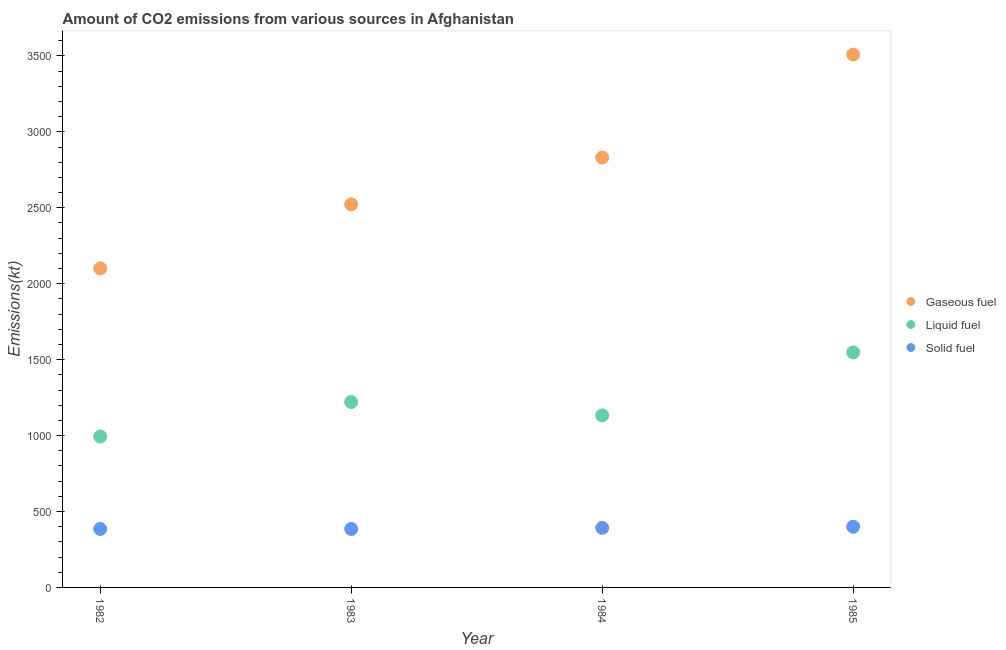What is the amount of co2 emissions from liquid fuel in 1984?
Offer a terse response. 1133.1. Across all years, what is the maximum amount of co2 emissions from solid fuel?
Offer a very short reply. 399.7. Across all years, what is the minimum amount of co2 emissions from solid fuel?
Offer a very short reply. 385.04. In which year was the amount of co2 emissions from gaseous fuel maximum?
Provide a short and direct response. 1985. What is the total amount of co2 emissions from solid fuel in the graph?
Give a very brief answer. 1562.14. What is the difference between the amount of co2 emissions from gaseous fuel in 1984 and that in 1985?
Give a very brief answer. -678.39. What is the difference between the amount of co2 emissions from gaseous fuel in 1983 and the amount of co2 emissions from liquid fuel in 1984?
Offer a very short reply. 1389.79. What is the average amount of co2 emissions from liquid fuel per year?
Keep it short and to the point. 1223.86. In the year 1983, what is the difference between the amount of co2 emissions from gaseous fuel and amount of co2 emissions from liquid fuel?
Provide a short and direct response. 1301.79. What is the ratio of the amount of co2 emissions from gaseous fuel in 1982 to that in 1983?
Provide a succinct answer. 0.83. Is the amount of co2 emissions from liquid fuel in 1983 less than that in 1985?
Make the answer very short. Yes. What is the difference between the highest and the second highest amount of co2 emissions from gaseous fuel?
Keep it short and to the point. 678.39. What is the difference between the highest and the lowest amount of co2 emissions from solid fuel?
Make the answer very short. 14.67. In how many years, is the amount of co2 emissions from liquid fuel greater than the average amount of co2 emissions from liquid fuel taken over all years?
Make the answer very short. 1. Is the sum of the amount of co2 emissions from liquid fuel in 1982 and 1985 greater than the maximum amount of co2 emissions from solid fuel across all years?
Provide a succinct answer. Yes. Does the amount of co2 emissions from gaseous fuel monotonically increase over the years?
Provide a short and direct response. Yes. How many dotlines are there?
Your answer should be compact. 3. How many years are there in the graph?
Your answer should be very brief. 4. Does the graph contain any zero values?
Ensure brevity in your answer.  No. Does the graph contain grids?
Your answer should be very brief. No. Where does the legend appear in the graph?
Your answer should be compact. Center right. What is the title of the graph?
Ensure brevity in your answer.  Amount of CO2 emissions from various sources in Afghanistan. What is the label or title of the X-axis?
Offer a very short reply. Year. What is the label or title of the Y-axis?
Your answer should be compact. Emissions(kt). What is the Emissions(kt) in Gaseous fuel in 1982?
Offer a terse response. 2101.19. What is the Emissions(kt) of Liquid fuel in 1982?
Your response must be concise. 993.76. What is the Emissions(kt) in Solid fuel in 1982?
Offer a terse response. 385.04. What is the Emissions(kt) of Gaseous fuel in 1983?
Your answer should be compact. 2522.9. What is the Emissions(kt) of Liquid fuel in 1983?
Give a very brief answer. 1221.11. What is the Emissions(kt) of Solid fuel in 1983?
Your answer should be very brief. 385.04. What is the Emissions(kt) in Gaseous fuel in 1984?
Your answer should be very brief. 2830.92. What is the Emissions(kt) in Liquid fuel in 1984?
Offer a terse response. 1133.1. What is the Emissions(kt) of Solid fuel in 1984?
Keep it short and to the point. 392.37. What is the Emissions(kt) of Gaseous fuel in 1985?
Ensure brevity in your answer.  3509.32. What is the Emissions(kt) in Liquid fuel in 1985?
Provide a succinct answer. 1547.47. What is the Emissions(kt) in Solid fuel in 1985?
Give a very brief answer. 399.7. Across all years, what is the maximum Emissions(kt) of Gaseous fuel?
Keep it short and to the point. 3509.32. Across all years, what is the maximum Emissions(kt) in Liquid fuel?
Ensure brevity in your answer.  1547.47. Across all years, what is the maximum Emissions(kt) of Solid fuel?
Your response must be concise. 399.7. Across all years, what is the minimum Emissions(kt) in Gaseous fuel?
Make the answer very short. 2101.19. Across all years, what is the minimum Emissions(kt) of Liquid fuel?
Make the answer very short. 993.76. Across all years, what is the minimum Emissions(kt) of Solid fuel?
Provide a succinct answer. 385.04. What is the total Emissions(kt) of Gaseous fuel in the graph?
Make the answer very short. 1.10e+04. What is the total Emissions(kt) of Liquid fuel in the graph?
Your answer should be very brief. 4895.44. What is the total Emissions(kt) of Solid fuel in the graph?
Your answer should be very brief. 1562.14. What is the difference between the Emissions(kt) of Gaseous fuel in 1982 and that in 1983?
Give a very brief answer. -421.7. What is the difference between the Emissions(kt) in Liquid fuel in 1982 and that in 1983?
Keep it short and to the point. -227.35. What is the difference between the Emissions(kt) of Solid fuel in 1982 and that in 1983?
Ensure brevity in your answer.  0. What is the difference between the Emissions(kt) in Gaseous fuel in 1982 and that in 1984?
Your response must be concise. -729.73. What is the difference between the Emissions(kt) of Liquid fuel in 1982 and that in 1984?
Ensure brevity in your answer.  -139.35. What is the difference between the Emissions(kt) of Solid fuel in 1982 and that in 1984?
Offer a very short reply. -7.33. What is the difference between the Emissions(kt) in Gaseous fuel in 1982 and that in 1985?
Your response must be concise. -1408.13. What is the difference between the Emissions(kt) of Liquid fuel in 1982 and that in 1985?
Your answer should be compact. -553.72. What is the difference between the Emissions(kt) of Solid fuel in 1982 and that in 1985?
Make the answer very short. -14.67. What is the difference between the Emissions(kt) in Gaseous fuel in 1983 and that in 1984?
Give a very brief answer. -308.03. What is the difference between the Emissions(kt) of Liquid fuel in 1983 and that in 1984?
Ensure brevity in your answer.  88.01. What is the difference between the Emissions(kt) in Solid fuel in 1983 and that in 1984?
Ensure brevity in your answer.  -7.33. What is the difference between the Emissions(kt) in Gaseous fuel in 1983 and that in 1985?
Make the answer very short. -986.42. What is the difference between the Emissions(kt) of Liquid fuel in 1983 and that in 1985?
Provide a short and direct response. -326.36. What is the difference between the Emissions(kt) of Solid fuel in 1983 and that in 1985?
Your answer should be very brief. -14.67. What is the difference between the Emissions(kt) in Gaseous fuel in 1984 and that in 1985?
Provide a short and direct response. -678.39. What is the difference between the Emissions(kt) of Liquid fuel in 1984 and that in 1985?
Offer a very short reply. -414.37. What is the difference between the Emissions(kt) in Solid fuel in 1984 and that in 1985?
Provide a succinct answer. -7.33. What is the difference between the Emissions(kt) of Gaseous fuel in 1982 and the Emissions(kt) of Liquid fuel in 1983?
Keep it short and to the point. 880.08. What is the difference between the Emissions(kt) of Gaseous fuel in 1982 and the Emissions(kt) of Solid fuel in 1983?
Keep it short and to the point. 1716.16. What is the difference between the Emissions(kt) of Liquid fuel in 1982 and the Emissions(kt) of Solid fuel in 1983?
Your response must be concise. 608.72. What is the difference between the Emissions(kt) in Gaseous fuel in 1982 and the Emissions(kt) in Liquid fuel in 1984?
Your answer should be compact. 968.09. What is the difference between the Emissions(kt) of Gaseous fuel in 1982 and the Emissions(kt) of Solid fuel in 1984?
Your answer should be very brief. 1708.82. What is the difference between the Emissions(kt) in Liquid fuel in 1982 and the Emissions(kt) in Solid fuel in 1984?
Your response must be concise. 601.39. What is the difference between the Emissions(kt) of Gaseous fuel in 1982 and the Emissions(kt) of Liquid fuel in 1985?
Keep it short and to the point. 553.72. What is the difference between the Emissions(kt) of Gaseous fuel in 1982 and the Emissions(kt) of Solid fuel in 1985?
Provide a succinct answer. 1701.49. What is the difference between the Emissions(kt) in Liquid fuel in 1982 and the Emissions(kt) in Solid fuel in 1985?
Your answer should be compact. 594.05. What is the difference between the Emissions(kt) in Gaseous fuel in 1983 and the Emissions(kt) in Liquid fuel in 1984?
Keep it short and to the point. 1389.79. What is the difference between the Emissions(kt) in Gaseous fuel in 1983 and the Emissions(kt) in Solid fuel in 1984?
Offer a terse response. 2130.53. What is the difference between the Emissions(kt) in Liquid fuel in 1983 and the Emissions(kt) in Solid fuel in 1984?
Your answer should be compact. 828.74. What is the difference between the Emissions(kt) in Gaseous fuel in 1983 and the Emissions(kt) in Liquid fuel in 1985?
Ensure brevity in your answer.  975.42. What is the difference between the Emissions(kt) of Gaseous fuel in 1983 and the Emissions(kt) of Solid fuel in 1985?
Make the answer very short. 2123.19. What is the difference between the Emissions(kt) of Liquid fuel in 1983 and the Emissions(kt) of Solid fuel in 1985?
Offer a terse response. 821.41. What is the difference between the Emissions(kt) of Gaseous fuel in 1984 and the Emissions(kt) of Liquid fuel in 1985?
Keep it short and to the point. 1283.45. What is the difference between the Emissions(kt) of Gaseous fuel in 1984 and the Emissions(kt) of Solid fuel in 1985?
Offer a terse response. 2431.22. What is the difference between the Emissions(kt) in Liquid fuel in 1984 and the Emissions(kt) in Solid fuel in 1985?
Keep it short and to the point. 733.4. What is the average Emissions(kt) in Gaseous fuel per year?
Keep it short and to the point. 2741.08. What is the average Emissions(kt) in Liquid fuel per year?
Give a very brief answer. 1223.86. What is the average Emissions(kt) of Solid fuel per year?
Make the answer very short. 390.54. In the year 1982, what is the difference between the Emissions(kt) in Gaseous fuel and Emissions(kt) in Liquid fuel?
Your response must be concise. 1107.43. In the year 1982, what is the difference between the Emissions(kt) of Gaseous fuel and Emissions(kt) of Solid fuel?
Provide a succinct answer. 1716.16. In the year 1982, what is the difference between the Emissions(kt) in Liquid fuel and Emissions(kt) in Solid fuel?
Keep it short and to the point. 608.72. In the year 1983, what is the difference between the Emissions(kt) of Gaseous fuel and Emissions(kt) of Liquid fuel?
Offer a terse response. 1301.79. In the year 1983, what is the difference between the Emissions(kt) of Gaseous fuel and Emissions(kt) of Solid fuel?
Offer a very short reply. 2137.86. In the year 1983, what is the difference between the Emissions(kt) of Liquid fuel and Emissions(kt) of Solid fuel?
Your answer should be very brief. 836.08. In the year 1984, what is the difference between the Emissions(kt) of Gaseous fuel and Emissions(kt) of Liquid fuel?
Offer a very short reply. 1697.82. In the year 1984, what is the difference between the Emissions(kt) in Gaseous fuel and Emissions(kt) in Solid fuel?
Offer a terse response. 2438.55. In the year 1984, what is the difference between the Emissions(kt) in Liquid fuel and Emissions(kt) in Solid fuel?
Provide a succinct answer. 740.73. In the year 1985, what is the difference between the Emissions(kt) in Gaseous fuel and Emissions(kt) in Liquid fuel?
Provide a succinct answer. 1961.85. In the year 1985, what is the difference between the Emissions(kt) in Gaseous fuel and Emissions(kt) in Solid fuel?
Keep it short and to the point. 3109.62. In the year 1985, what is the difference between the Emissions(kt) of Liquid fuel and Emissions(kt) of Solid fuel?
Keep it short and to the point. 1147.77. What is the ratio of the Emissions(kt) in Gaseous fuel in 1982 to that in 1983?
Offer a terse response. 0.83. What is the ratio of the Emissions(kt) of Liquid fuel in 1982 to that in 1983?
Offer a terse response. 0.81. What is the ratio of the Emissions(kt) of Gaseous fuel in 1982 to that in 1984?
Ensure brevity in your answer.  0.74. What is the ratio of the Emissions(kt) of Liquid fuel in 1982 to that in 1984?
Give a very brief answer. 0.88. What is the ratio of the Emissions(kt) in Solid fuel in 1982 to that in 1984?
Ensure brevity in your answer.  0.98. What is the ratio of the Emissions(kt) in Gaseous fuel in 1982 to that in 1985?
Your answer should be compact. 0.6. What is the ratio of the Emissions(kt) of Liquid fuel in 1982 to that in 1985?
Keep it short and to the point. 0.64. What is the ratio of the Emissions(kt) of Solid fuel in 1982 to that in 1985?
Your response must be concise. 0.96. What is the ratio of the Emissions(kt) of Gaseous fuel in 1983 to that in 1984?
Give a very brief answer. 0.89. What is the ratio of the Emissions(kt) of Liquid fuel in 1983 to that in 1984?
Provide a short and direct response. 1.08. What is the ratio of the Emissions(kt) of Solid fuel in 1983 to that in 1984?
Offer a terse response. 0.98. What is the ratio of the Emissions(kt) in Gaseous fuel in 1983 to that in 1985?
Offer a very short reply. 0.72. What is the ratio of the Emissions(kt) of Liquid fuel in 1983 to that in 1985?
Make the answer very short. 0.79. What is the ratio of the Emissions(kt) in Solid fuel in 1983 to that in 1985?
Provide a succinct answer. 0.96. What is the ratio of the Emissions(kt) of Gaseous fuel in 1984 to that in 1985?
Give a very brief answer. 0.81. What is the ratio of the Emissions(kt) in Liquid fuel in 1984 to that in 1985?
Your response must be concise. 0.73. What is the ratio of the Emissions(kt) in Solid fuel in 1984 to that in 1985?
Give a very brief answer. 0.98. What is the difference between the highest and the second highest Emissions(kt) of Gaseous fuel?
Make the answer very short. 678.39. What is the difference between the highest and the second highest Emissions(kt) of Liquid fuel?
Give a very brief answer. 326.36. What is the difference between the highest and the second highest Emissions(kt) in Solid fuel?
Give a very brief answer. 7.33. What is the difference between the highest and the lowest Emissions(kt) of Gaseous fuel?
Your answer should be very brief. 1408.13. What is the difference between the highest and the lowest Emissions(kt) in Liquid fuel?
Make the answer very short. 553.72. What is the difference between the highest and the lowest Emissions(kt) of Solid fuel?
Your response must be concise. 14.67. 